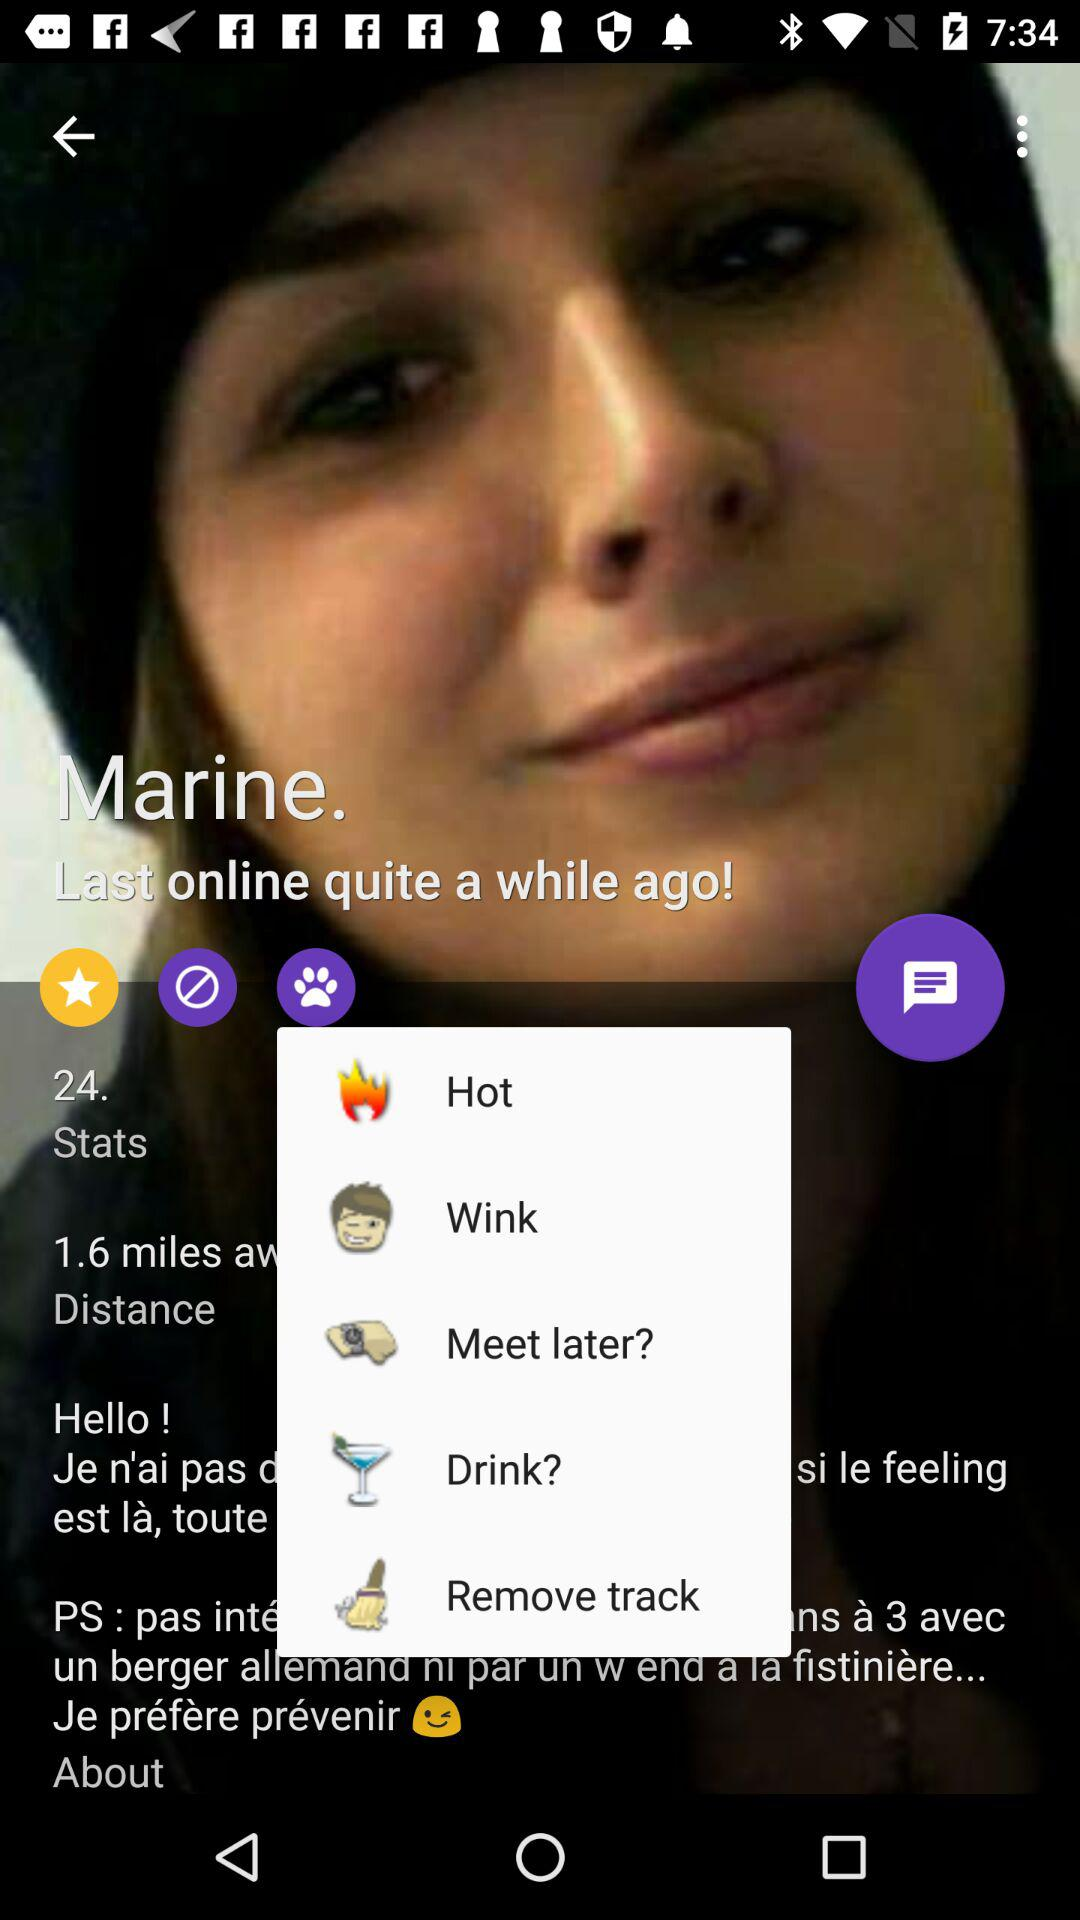How many stares are given here?
When the provided information is insufficient, respond with <no answer>. <no answer> 